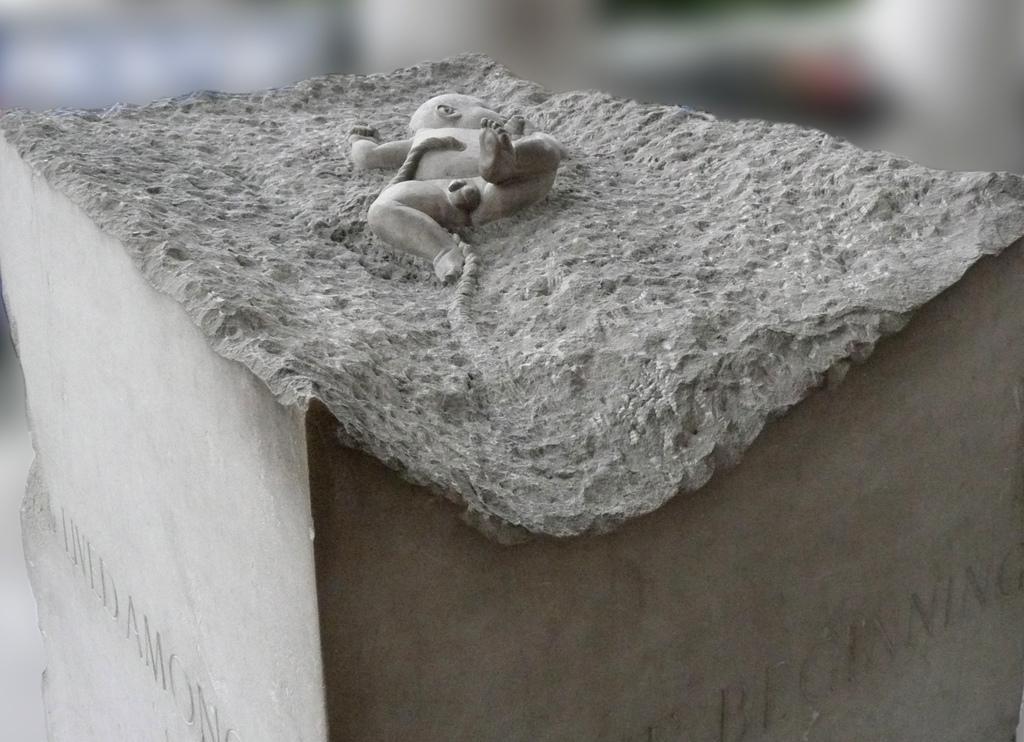Describe this image in one or two sentences. In this image on a pole there is a statue of a baby. The background is blurry. 